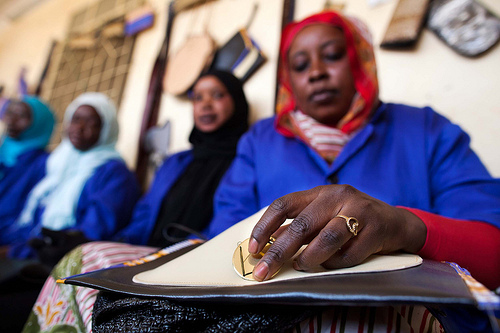<image>
Can you confirm if the glass is to the right of the shirt? No. The glass is not to the right of the shirt. The horizontal positioning shows a different relationship. 